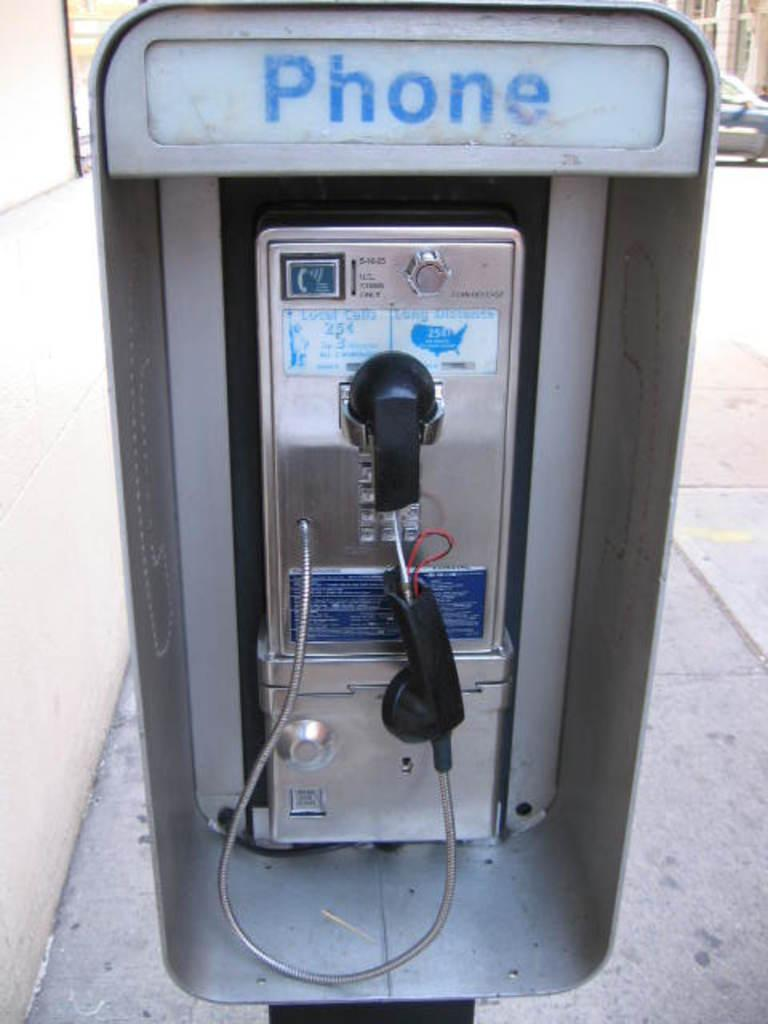Provide a one-sentence caption for the provided image. An old fashioned phone booth with Phone written on it. 